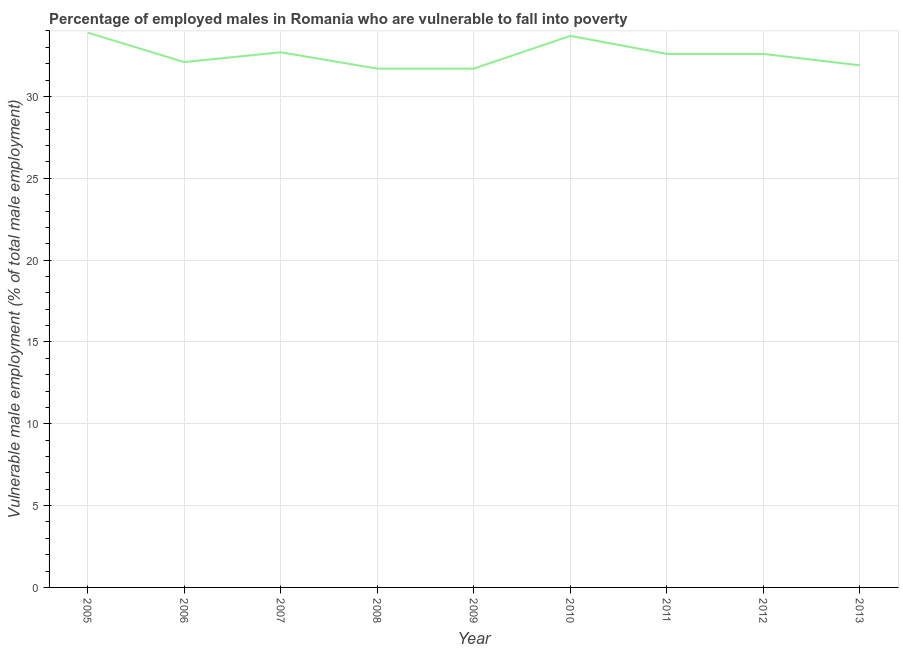What is the percentage of employed males who are vulnerable to fall into poverty in 2007?
Your answer should be compact. 32.7. Across all years, what is the maximum percentage of employed males who are vulnerable to fall into poverty?
Your answer should be very brief. 33.9. Across all years, what is the minimum percentage of employed males who are vulnerable to fall into poverty?
Offer a terse response. 31.7. In which year was the percentage of employed males who are vulnerable to fall into poverty maximum?
Provide a succinct answer. 2005. In which year was the percentage of employed males who are vulnerable to fall into poverty minimum?
Provide a short and direct response. 2008. What is the sum of the percentage of employed males who are vulnerable to fall into poverty?
Provide a succinct answer. 292.9. What is the difference between the percentage of employed males who are vulnerable to fall into poverty in 2009 and 2010?
Keep it short and to the point. -2. What is the average percentage of employed males who are vulnerable to fall into poverty per year?
Your answer should be compact. 32.54. What is the median percentage of employed males who are vulnerable to fall into poverty?
Make the answer very short. 32.6. What is the ratio of the percentage of employed males who are vulnerable to fall into poverty in 2006 to that in 2007?
Ensure brevity in your answer.  0.98. Is the difference between the percentage of employed males who are vulnerable to fall into poverty in 2006 and 2010 greater than the difference between any two years?
Offer a terse response. No. What is the difference between the highest and the second highest percentage of employed males who are vulnerable to fall into poverty?
Offer a very short reply. 0.2. Is the sum of the percentage of employed males who are vulnerable to fall into poverty in 2006 and 2010 greater than the maximum percentage of employed males who are vulnerable to fall into poverty across all years?
Give a very brief answer. Yes. What is the difference between the highest and the lowest percentage of employed males who are vulnerable to fall into poverty?
Make the answer very short. 2.2. What is the difference between two consecutive major ticks on the Y-axis?
Give a very brief answer. 5. Are the values on the major ticks of Y-axis written in scientific E-notation?
Make the answer very short. No. What is the title of the graph?
Provide a short and direct response. Percentage of employed males in Romania who are vulnerable to fall into poverty. What is the label or title of the X-axis?
Provide a succinct answer. Year. What is the label or title of the Y-axis?
Provide a short and direct response. Vulnerable male employment (% of total male employment). What is the Vulnerable male employment (% of total male employment) in 2005?
Offer a very short reply. 33.9. What is the Vulnerable male employment (% of total male employment) of 2006?
Provide a short and direct response. 32.1. What is the Vulnerable male employment (% of total male employment) in 2007?
Make the answer very short. 32.7. What is the Vulnerable male employment (% of total male employment) of 2008?
Offer a very short reply. 31.7. What is the Vulnerable male employment (% of total male employment) of 2009?
Provide a short and direct response. 31.7. What is the Vulnerable male employment (% of total male employment) in 2010?
Make the answer very short. 33.7. What is the Vulnerable male employment (% of total male employment) in 2011?
Offer a terse response. 32.6. What is the Vulnerable male employment (% of total male employment) in 2012?
Keep it short and to the point. 32.6. What is the Vulnerable male employment (% of total male employment) of 2013?
Your answer should be very brief. 31.9. What is the difference between the Vulnerable male employment (% of total male employment) in 2005 and 2009?
Provide a short and direct response. 2.2. What is the difference between the Vulnerable male employment (% of total male employment) in 2005 and 2010?
Offer a terse response. 0.2. What is the difference between the Vulnerable male employment (% of total male employment) in 2005 and 2011?
Your answer should be compact. 1.3. What is the difference between the Vulnerable male employment (% of total male employment) in 2006 and 2009?
Make the answer very short. 0.4. What is the difference between the Vulnerable male employment (% of total male employment) in 2006 and 2010?
Ensure brevity in your answer.  -1.6. What is the difference between the Vulnerable male employment (% of total male employment) in 2006 and 2011?
Provide a short and direct response. -0.5. What is the difference between the Vulnerable male employment (% of total male employment) in 2006 and 2012?
Your answer should be very brief. -0.5. What is the difference between the Vulnerable male employment (% of total male employment) in 2007 and 2010?
Offer a terse response. -1. What is the difference between the Vulnerable male employment (% of total male employment) in 2007 and 2011?
Give a very brief answer. 0.1. What is the difference between the Vulnerable male employment (% of total male employment) in 2007 and 2012?
Your response must be concise. 0.1. What is the difference between the Vulnerable male employment (% of total male employment) in 2008 and 2010?
Your answer should be compact. -2. What is the difference between the Vulnerable male employment (% of total male employment) in 2008 and 2012?
Make the answer very short. -0.9. What is the difference between the Vulnerable male employment (% of total male employment) in 2009 and 2012?
Offer a terse response. -0.9. What is the difference between the Vulnerable male employment (% of total male employment) in 2010 and 2011?
Keep it short and to the point. 1.1. What is the difference between the Vulnerable male employment (% of total male employment) in 2010 and 2012?
Give a very brief answer. 1.1. What is the difference between the Vulnerable male employment (% of total male employment) in 2011 and 2013?
Ensure brevity in your answer.  0.7. What is the difference between the Vulnerable male employment (% of total male employment) in 2012 and 2013?
Ensure brevity in your answer.  0.7. What is the ratio of the Vulnerable male employment (% of total male employment) in 2005 to that in 2006?
Ensure brevity in your answer.  1.06. What is the ratio of the Vulnerable male employment (% of total male employment) in 2005 to that in 2007?
Provide a short and direct response. 1.04. What is the ratio of the Vulnerable male employment (% of total male employment) in 2005 to that in 2008?
Offer a terse response. 1.07. What is the ratio of the Vulnerable male employment (% of total male employment) in 2005 to that in 2009?
Your response must be concise. 1.07. What is the ratio of the Vulnerable male employment (% of total male employment) in 2005 to that in 2011?
Your response must be concise. 1.04. What is the ratio of the Vulnerable male employment (% of total male employment) in 2005 to that in 2012?
Provide a succinct answer. 1.04. What is the ratio of the Vulnerable male employment (% of total male employment) in 2005 to that in 2013?
Your response must be concise. 1.06. What is the ratio of the Vulnerable male employment (% of total male employment) in 2006 to that in 2009?
Offer a terse response. 1.01. What is the ratio of the Vulnerable male employment (% of total male employment) in 2006 to that in 2010?
Offer a very short reply. 0.95. What is the ratio of the Vulnerable male employment (% of total male employment) in 2007 to that in 2008?
Your response must be concise. 1.03. What is the ratio of the Vulnerable male employment (% of total male employment) in 2007 to that in 2009?
Provide a short and direct response. 1.03. What is the ratio of the Vulnerable male employment (% of total male employment) in 2007 to that in 2010?
Provide a short and direct response. 0.97. What is the ratio of the Vulnerable male employment (% of total male employment) in 2007 to that in 2011?
Offer a very short reply. 1. What is the ratio of the Vulnerable male employment (% of total male employment) in 2007 to that in 2012?
Your response must be concise. 1. What is the ratio of the Vulnerable male employment (% of total male employment) in 2007 to that in 2013?
Your response must be concise. 1.02. What is the ratio of the Vulnerable male employment (% of total male employment) in 2008 to that in 2009?
Provide a short and direct response. 1. What is the ratio of the Vulnerable male employment (% of total male employment) in 2008 to that in 2010?
Provide a short and direct response. 0.94. What is the ratio of the Vulnerable male employment (% of total male employment) in 2008 to that in 2011?
Provide a short and direct response. 0.97. What is the ratio of the Vulnerable male employment (% of total male employment) in 2008 to that in 2013?
Your answer should be compact. 0.99. What is the ratio of the Vulnerable male employment (% of total male employment) in 2009 to that in 2010?
Make the answer very short. 0.94. What is the ratio of the Vulnerable male employment (% of total male employment) in 2010 to that in 2011?
Make the answer very short. 1.03. What is the ratio of the Vulnerable male employment (% of total male employment) in 2010 to that in 2012?
Offer a very short reply. 1.03. What is the ratio of the Vulnerable male employment (% of total male employment) in 2010 to that in 2013?
Make the answer very short. 1.06. What is the ratio of the Vulnerable male employment (% of total male employment) in 2011 to that in 2012?
Provide a short and direct response. 1. What is the ratio of the Vulnerable male employment (% of total male employment) in 2012 to that in 2013?
Ensure brevity in your answer.  1.02. 